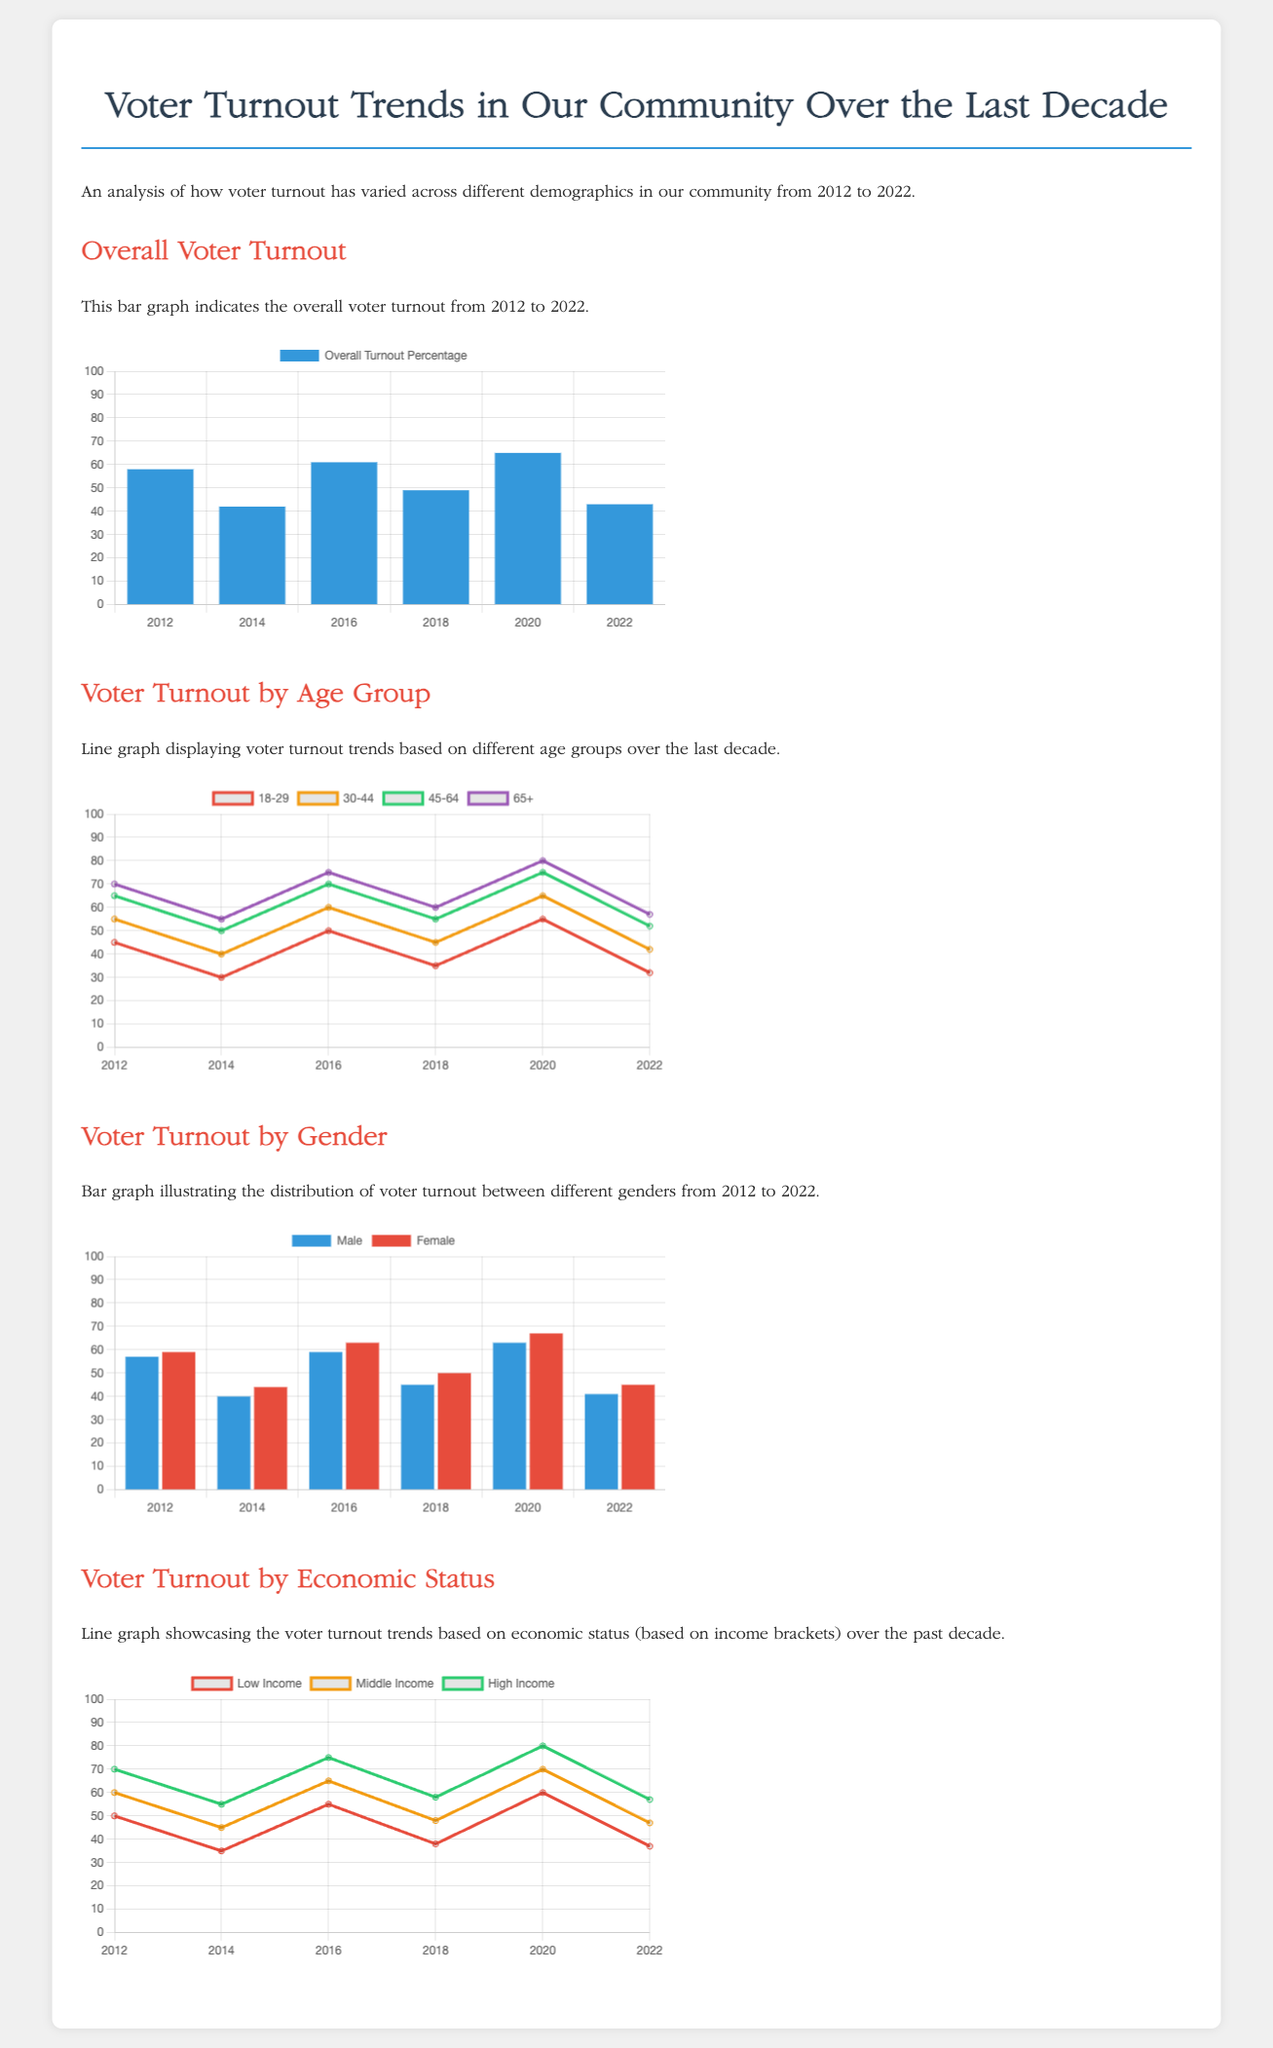What was the overall voter turnout percentage in 2020? The overall voter turnout percentage for 2020, as indicated in the bar graph, is 65.
Answer: 65 Which age group had the highest voter turnout in 2022? In 2022, the age group 65+ had the highest voter turnout, with 57%.
Answer: 65+ What is the turnout percentage for females in 2016? The turnout percentage for females in 2016 is 63%, as shown in the gender bar graph.
Answer: 63 What was the voter turnout percentage for low-income individuals in 2014? The voter turnout percentage for low-income individuals in 2014, as displayed in the economic status line graph, is 35%.
Answer: 35 Which age group showed the least turnout in 2014? The age group 18-29 had the least turnout in 2014, with only 30%.
Answer: 18-29 What is the trend for middle-income voter turnout from 2012 to 2022? The middle-income voter turnout trend increases from 60% in 2012 to 47% in 2022, showing fluctuations over the decade.
Answer: Fluctuations What color represents male voter turnout in the gender chart? The color representing male voter turnout in the chart is blue.
Answer: Blue How many age groups are displayed in the voter turnout by age group chart? There are four age groups displayed in the chart.
Answer: Four age groups What was the overall turnout percentage in 2012? The overall turnout percentage in 2012 is 58%.
Answer: 58 